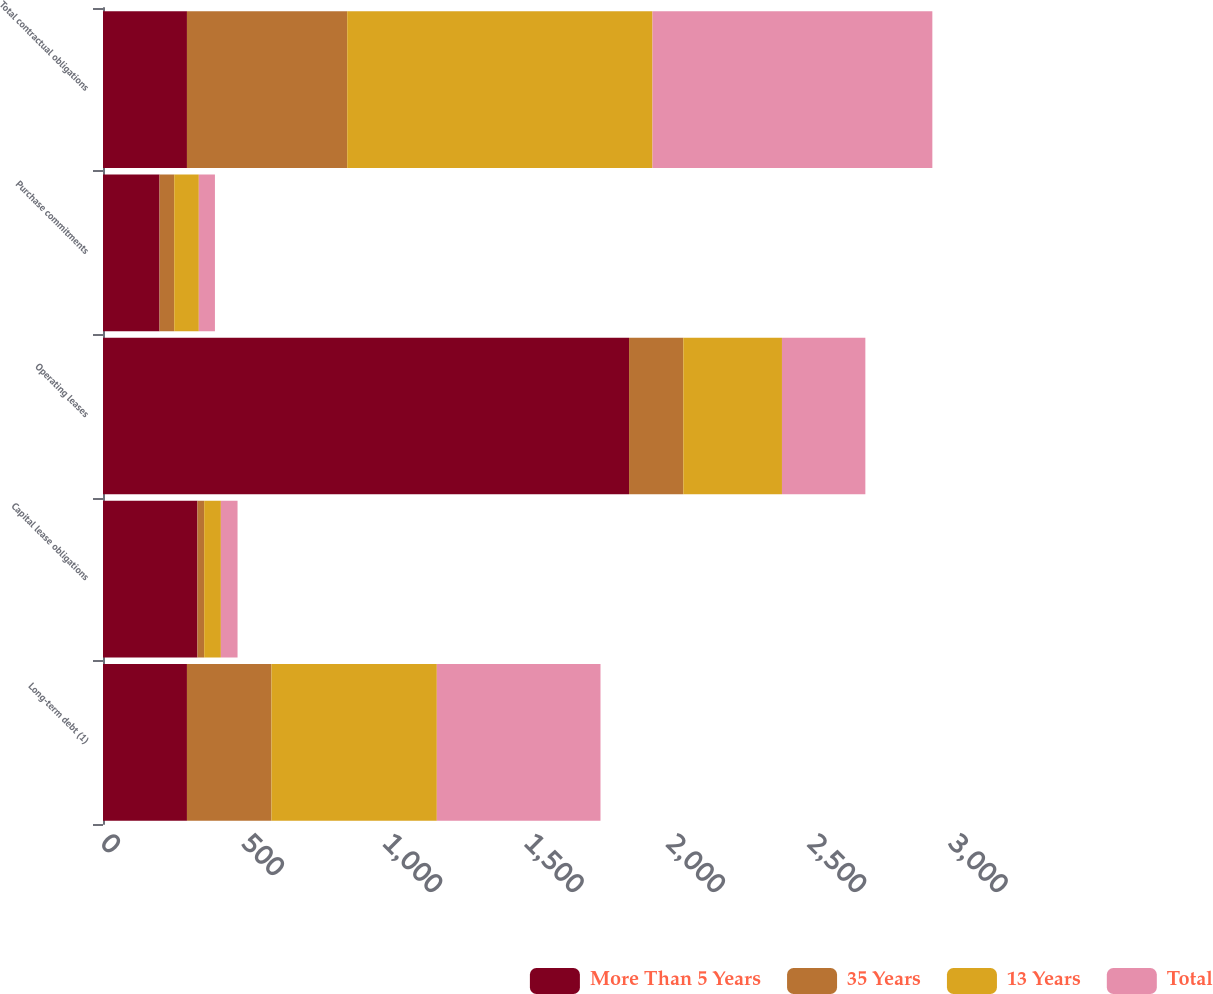Convert chart to OTSL. <chart><loc_0><loc_0><loc_500><loc_500><stacked_bar_chart><ecel><fcel>Long-term debt (1)<fcel>Capital lease obligations<fcel>Operating leases<fcel>Purchase commitments<fcel>Total contractual obligations<nl><fcel>More Than 5 Years<fcel>297<fcel>334<fcel>1861<fcel>200<fcel>297<nl><fcel>35 Years<fcel>299<fcel>24<fcel>192<fcel>52<fcel>567<nl><fcel>13 Years<fcel>585<fcel>59<fcel>349<fcel>87<fcel>1080<nl><fcel>Total<fcel>579<fcel>59<fcel>295<fcel>57<fcel>990<nl></chart> 